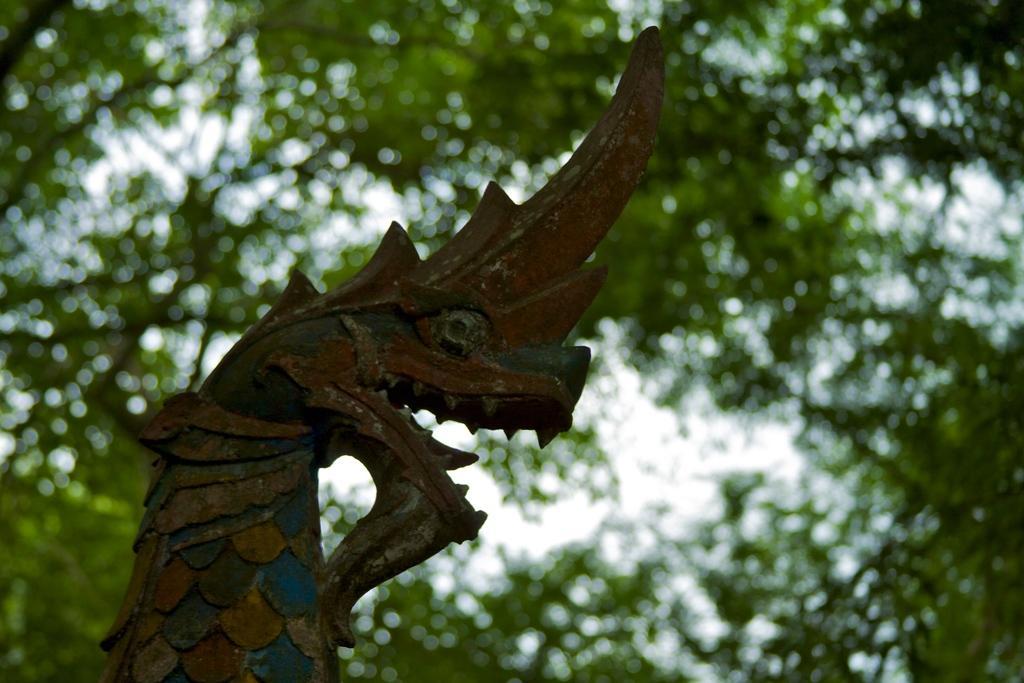Could you give a brief overview of what you see in this image? In this image I can see a structure which is in the shape of a dragon which is blue, yellow and brown in color. In the background I can see few trees and the sky. 